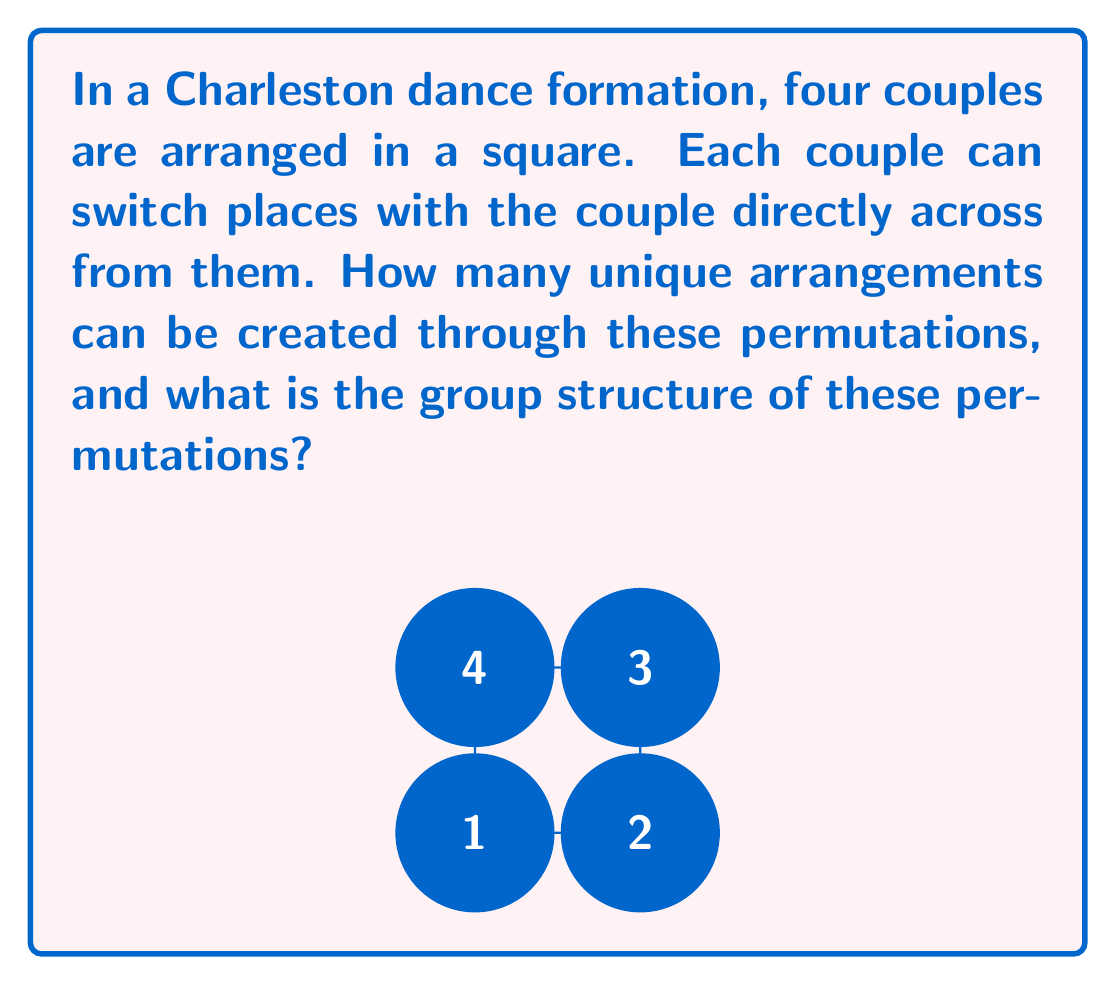Provide a solution to this math problem. Let's approach this step-by-step:

1) First, we need to identify the possible permutations:
   - Couples 1 and 3 can switch
   - Couples 2 and 4 can switch

2) Let's represent these permutations in cycle notation:
   - $(1 3)$ for couples 1 and 3 switching
   - $(2 4)$ for couples 2 and 4 switching

3) Now, let's list all possible combinations:
   - Identity permutation (no switches): $e$
   - Only 1 and 3 switch: $(1 3)$
   - Only 2 and 4 switch: $(2 4)$
   - Both pairs switch: $(1 3)(2 4)$

4) We can see that there are 4 unique arrangements in total.

5) To determine the group structure, let's examine the properties:
   - The operation is composition of permutations
   - The identity element is $e$
   - Each element is its own inverse: $(1 3)(1 3) = e$, $(2 4)(2 4) = e$
   - The elements commute: $(1 3)(2 4) = (2 4)(1 3)$

6) These properties match the Klein four-group, also known as $V_4$ or $\mathbb{Z}_2 \times \mathbb{Z}_2$.

7) The Cayley table for this group would be:

   $$\begin{array}{c|cccc}
     & e & (1 3) & (2 4) & (1 3)(2 4) \\
   \hline
   e & e & (1 3) & (2 4) & (1 3)(2 4) \\
   (1 3) & (1 3) & e & (1 3)(2 4) & (2 4) \\
   (2 4) & (2 4) & (1 3)(2 4) & e & (1 3) \\
   (1 3)(2 4) & (1 3)(2 4) & (2 4) & (1 3) & e
   \end{array}$$
Answer: 4 unique arrangements; Klein four-group ($V_4$ or $\mathbb{Z}_2 \times \mathbb{Z}_2$) 